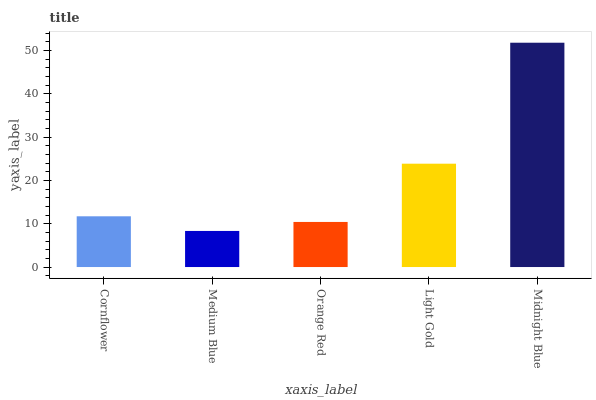Is Medium Blue the minimum?
Answer yes or no. Yes. Is Midnight Blue the maximum?
Answer yes or no. Yes. Is Orange Red the minimum?
Answer yes or no. No. Is Orange Red the maximum?
Answer yes or no. No. Is Orange Red greater than Medium Blue?
Answer yes or no. Yes. Is Medium Blue less than Orange Red?
Answer yes or no. Yes. Is Medium Blue greater than Orange Red?
Answer yes or no. No. Is Orange Red less than Medium Blue?
Answer yes or no. No. Is Cornflower the high median?
Answer yes or no. Yes. Is Cornflower the low median?
Answer yes or no. Yes. Is Light Gold the high median?
Answer yes or no. No. Is Midnight Blue the low median?
Answer yes or no. No. 